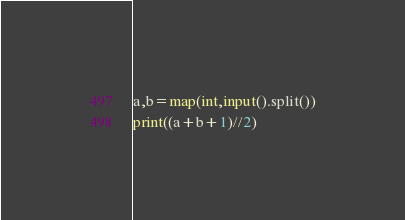<code> <loc_0><loc_0><loc_500><loc_500><_Python_>a,b=map(int,input().split())
print((a+b+1)//2)</code> 